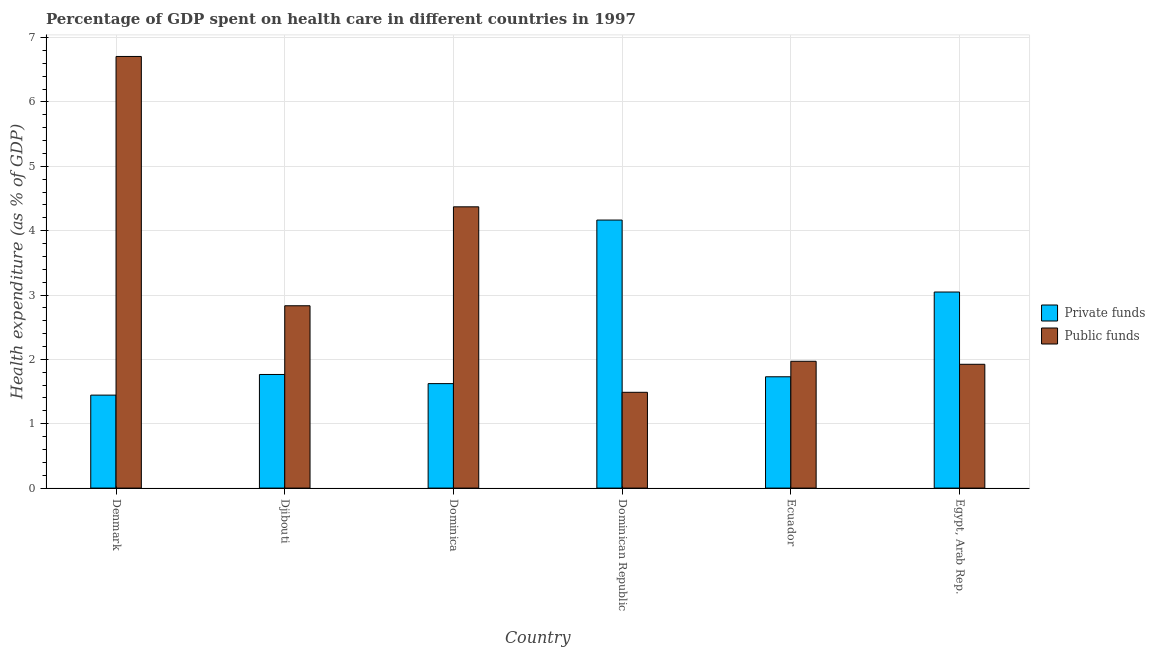How many different coloured bars are there?
Offer a terse response. 2. How many groups of bars are there?
Ensure brevity in your answer.  6. Are the number of bars per tick equal to the number of legend labels?
Your answer should be compact. Yes. Are the number of bars on each tick of the X-axis equal?
Give a very brief answer. Yes. How many bars are there on the 2nd tick from the left?
Keep it short and to the point. 2. What is the label of the 4th group of bars from the left?
Keep it short and to the point. Dominican Republic. What is the amount of public funds spent in healthcare in Egypt, Arab Rep.?
Your answer should be compact. 1.92. Across all countries, what is the maximum amount of private funds spent in healthcare?
Provide a succinct answer. 4.16. Across all countries, what is the minimum amount of public funds spent in healthcare?
Provide a succinct answer. 1.49. In which country was the amount of public funds spent in healthcare minimum?
Provide a short and direct response. Dominican Republic. What is the total amount of public funds spent in healthcare in the graph?
Make the answer very short. 19.29. What is the difference between the amount of public funds spent in healthcare in Ecuador and that in Egypt, Arab Rep.?
Offer a terse response. 0.05. What is the difference between the amount of private funds spent in healthcare in Denmark and the amount of public funds spent in healthcare in Dominica?
Offer a very short reply. -2.93. What is the average amount of public funds spent in healthcare per country?
Your answer should be compact. 3.22. What is the difference between the amount of private funds spent in healthcare and amount of public funds spent in healthcare in Egypt, Arab Rep.?
Provide a succinct answer. 1.12. In how many countries, is the amount of public funds spent in healthcare greater than 5 %?
Offer a terse response. 1. What is the ratio of the amount of private funds spent in healthcare in Denmark to that in Ecuador?
Give a very brief answer. 0.84. What is the difference between the highest and the second highest amount of public funds spent in healthcare?
Keep it short and to the point. 2.34. What is the difference between the highest and the lowest amount of public funds spent in healthcare?
Provide a short and direct response. 5.22. In how many countries, is the amount of private funds spent in healthcare greater than the average amount of private funds spent in healthcare taken over all countries?
Your answer should be compact. 2. What does the 2nd bar from the left in Denmark represents?
Keep it short and to the point. Public funds. What does the 1st bar from the right in Djibouti represents?
Make the answer very short. Public funds. How many bars are there?
Your answer should be very brief. 12. Are all the bars in the graph horizontal?
Offer a very short reply. No. How many countries are there in the graph?
Offer a very short reply. 6. What is the difference between two consecutive major ticks on the Y-axis?
Offer a terse response. 1. Does the graph contain any zero values?
Your answer should be compact. No. Where does the legend appear in the graph?
Give a very brief answer. Center right. How many legend labels are there?
Make the answer very short. 2. How are the legend labels stacked?
Ensure brevity in your answer.  Vertical. What is the title of the graph?
Give a very brief answer. Percentage of GDP spent on health care in different countries in 1997. What is the label or title of the Y-axis?
Give a very brief answer. Health expenditure (as % of GDP). What is the Health expenditure (as % of GDP) of Private funds in Denmark?
Offer a very short reply. 1.44. What is the Health expenditure (as % of GDP) in Public funds in Denmark?
Your answer should be very brief. 6.71. What is the Health expenditure (as % of GDP) in Private funds in Djibouti?
Your answer should be compact. 1.77. What is the Health expenditure (as % of GDP) of Public funds in Djibouti?
Make the answer very short. 2.83. What is the Health expenditure (as % of GDP) in Private funds in Dominica?
Provide a succinct answer. 1.62. What is the Health expenditure (as % of GDP) of Public funds in Dominica?
Your response must be concise. 4.37. What is the Health expenditure (as % of GDP) in Private funds in Dominican Republic?
Provide a short and direct response. 4.16. What is the Health expenditure (as % of GDP) in Public funds in Dominican Republic?
Provide a succinct answer. 1.49. What is the Health expenditure (as % of GDP) of Private funds in Ecuador?
Offer a terse response. 1.73. What is the Health expenditure (as % of GDP) of Public funds in Ecuador?
Provide a short and direct response. 1.97. What is the Health expenditure (as % of GDP) in Private funds in Egypt, Arab Rep.?
Provide a succinct answer. 3.05. What is the Health expenditure (as % of GDP) of Public funds in Egypt, Arab Rep.?
Provide a short and direct response. 1.92. Across all countries, what is the maximum Health expenditure (as % of GDP) of Private funds?
Provide a succinct answer. 4.16. Across all countries, what is the maximum Health expenditure (as % of GDP) of Public funds?
Offer a terse response. 6.71. Across all countries, what is the minimum Health expenditure (as % of GDP) of Private funds?
Offer a terse response. 1.44. Across all countries, what is the minimum Health expenditure (as % of GDP) in Public funds?
Make the answer very short. 1.49. What is the total Health expenditure (as % of GDP) in Private funds in the graph?
Keep it short and to the point. 13.77. What is the total Health expenditure (as % of GDP) of Public funds in the graph?
Your answer should be very brief. 19.29. What is the difference between the Health expenditure (as % of GDP) of Private funds in Denmark and that in Djibouti?
Your answer should be compact. -0.32. What is the difference between the Health expenditure (as % of GDP) in Public funds in Denmark and that in Djibouti?
Offer a very short reply. 3.87. What is the difference between the Health expenditure (as % of GDP) of Private funds in Denmark and that in Dominica?
Offer a terse response. -0.18. What is the difference between the Health expenditure (as % of GDP) of Public funds in Denmark and that in Dominica?
Provide a short and direct response. 2.34. What is the difference between the Health expenditure (as % of GDP) of Private funds in Denmark and that in Dominican Republic?
Offer a terse response. -2.72. What is the difference between the Health expenditure (as % of GDP) of Public funds in Denmark and that in Dominican Republic?
Give a very brief answer. 5.22. What is the difference between the Health expenditure (as % of GDP) of Private funds in Denmark and that in Ecuador?
Offer a terse response. -0.28. What is the difference between the Health expenditure (as % of GDP) of Public funds in Denmark and that in Ecuador?
Offer a very short reply. 4.74. What is the difference between the Health expenditure (as % of GDP) of Private funds in Denmark and that in Egypt, Arab Rep.?
Your answer should be compact. -1.6. What is the difference between the Health expenditure (as % of GDP) of Public funds in Denmark and that in Egypt, Arab Rep.?
Offer a terse response. 4.78. What is the difference between the Health expenditure (as % of GDP) of Private funds in Djibouti and that in Dominica?
Provide a succinct answer. 0.14. What is the difference between the Health expenditure (as % of GDP) in Public funds in Djibouti and that in Dominica?
Keep it short and to the point. -1.54. What is the difference between the Health expenditure (as % of GDP) of Private funds in Djibouti and that in Dominican Republic?
Your response must be concise. -2.4. What is the difference between the Health expenditure (as % of GDP) of Public funds in Djibouti and that in Dominican Republic?
Make the answer very short. 1.34. What is the difference between the Health expenditure (as % of GDP) in Private funds in Djibouti and that in Ecuador?
Your response must be concise. 0.04. What is the difference between the Health expenditure (as % of GDP) in Public funds in Djibouti and that in Ecuador?
Make the answer very short. 0.86. What is the difference between the Health expenditure (as % of GDP) of Private funds in Djibouti and that in Egypt, Arab Rep.?
Provide a succinct answer. -1.28. What is the difference between the Health expenditure (as % of GDP) of Public funds in Djibouti and that in Egypt, Arab Rep.?
Provide a short and direct response. 0.91. What is the difference between the Health expenditure (as % of GDP) in Private funds in Dominica and that in Dominican Republic?
Offer a terse response. -2.54. What is the difference between the Health expenditure (as % of GDP) in Public funds in Dominica and that in Dominican Republic?
Make the answer very short. 2.88. What is the difference between the Health expenditure (as % of GDP) in Private funds in Dominica and that in Ecuador?
Provide a short and direct response. -0.11. What is the difference between the Health expenditure (as % of GDP) in Public funds in Dominica and that in Ecuador?
Provide a succinct answer. 2.4. What is the difference between the Health expenditure (as % of GDP) of Private funds in Dominica and that in Egypt, Arab Rep.?
Make the answer very short. -1.42. What is the difference between the Health expenditure (as % of GDP) of Public funds in Dominica and that in Egypt, Arab Rep.?
Offer a very short reply. 2.45. What is the difference between the Health expenditure (as % of GDP) in Private funds in Dominican Republic and that in Ecuador?
Your response must be concise. 2.43. What is the difference between the Health expenditure (as % of GDP) of Public funds in Dominican Republic and that in Ecuador?
Offer a very short reply. -0.48. What is the difference between the Health expenditure (as % of GDP) of Private funds in Dominican Republic and that in Egypt, Arab Rep.?
Make the answer very short. 1.12. What is the difference between the Health expenditure (as % of GDP) in Public funds in Dominican Republic and that in Egypt, Arab Rep.?
Ensure brevity in your answer.  -0.44. What is the difference between the Health expenditure (as % of GDP) of Private funds in Ecuador and that in Egypt, Arab Rep.?
Offer a terse response. -1.32. What is the difference between the Health expenditure (as % of GDP) in Public funds in Ecuador and that in Egypt, Arab Rep.?
Your answer should be very brief. 0.05. What is the difference between the Health expenditure (as % of GDP) in Private funds in Denmark and the Health expenditure (as % of GDP) in Public funds in Djibouti?
Your answer should be compact. -1.39. What is the difference between the Health expenditure (as % of GDP) in Private funds in Denmark and the Health expenditure (as % of GDP) in Public funds in Dominica?
Your response must be concise. -2.93. What is the difference between the Health expenditure (as % of GDP) of Private funds in Denmark and the Health expenditure (as % of GDP) of Public funds in Dominican Republic?
Your answer should be very brief. -0.04. What is the difference between the Health expenditure (as % of GDP) of Private funds in Denmark and the Health expenditure (as % of GDP) of Public funds in Ecuador?
Your response must be concise. -0.53. What is the difference between the Health expenditure (as % of GDP) of Private funds in Denmark and the Health expenditure (as % of GDP) of Public funds in Egypt, Arab Rep.?
Give a very brief answer. -0.48. What is the difference between the Health expenditure (as % of GDP) of Private funds in Djibouti and the Health expenditure (as % of GDP) of Public funds in Dominica?
Give a very brief answer. -2.6. What is the difference between the Health expenditure (as % of GDP) in Private funds in Djibouti and the Health expenditure (as % of GDP) in Public funds in Dominican Republic?
Provide a succinct answer. 0.28. What is the difference between the Health expenditure (as % of GDP) in Private funds in Djibouti and the Health expenditure (as % of GDP) in Public funds in Ecuador?
Provide a succinct answer. -0.21. What is the difference between the Health expenditure (as % of GDP) of Private funds in Djibouti and the Health expenditure (as % of GDP) of Public funds in Egypt, Arab Rep.?
Provide a short and direct response. -0.16. What is the difference between the Health expenditure (as % of GDP) of Private funds in Dominica and the Health expenditure (as % of GDP) of Public funds in Dominican Republic?
Give a very brief answer. 0.14. What is the difference between the Health expenditure (as % of GDP) of Private funds in Dominica and the Health expenditure (as % of GDP) of Public funds in Ecuador?
Your answer should be compact. -0.35. What is the difference between the Health expenditure (as % of GDP) in Private funds in Dominica and the Health expenditure (as % of GDP) in Public funds in Egypt, Arab Rep.?
Keep it short and to the point. -0.3. What is the difference between the Health expenditure (as % of GDP) of Private funds in Dominican Republic and the Health expenditure (as % of GDP) of Public funds in Ecuador?
Offer a terse response. 2.19. What is the difference between the Health expenditure (as % of GDP) in Private funds in Dominican Republic and the Health expenditure (as % of GDP) in Public funds in Egypt, Arab Rep.?
Your answer should be very brief. 2.24. What is the difference between the Health expenditure (as % of GDP) of Private funds in Ecuador and the Health expenditure (as % of GDP) of Public funds in Egypt, Arab Rep.?
Your answer should be very brief. -0.19. What is the average Health expenditure (as % of GDP) in Private funds per country?
Offer a very short reply. 2.3. What is the average Health expenditure (as % of GDP) of Public funds per country?
Your answer should be very brief. 3.22. What is the difference between the Health expenditure (as % of GDP) of Private funds and Health expenditure (as % of GDP) of Public funds in Denmark?
Keep it short and to the point. -5.26. What is the difference between the Health expenditure (as % of GDP) of Private funds and Health expenditure (as % of GDP) of Public funds in Djibouti?
Make the answer very short. -1.07. What is the difference between the Health expenditure (as % of GDP) of Private funds and Health expenditure (as % of GDP) of Public funds in Dominica?
Your answer should be compact. -2.75. What is the difference between the Health expenditure (as % of GDP) in Private funds and Health expenditure (as % of GDP) in Public funds in Dominican Republic?
Keep it short and to the point. 2.68. What is the difference between the Health expenditure (as % of GDP) of Private funds and Health expenditure (as % of GDP) of Public funds in Ecuador?
Your answer should be compact. -0.24. What is the difference between the Health expenditure (as % of GDP) in Private funds and Health expenditure (as % of GDP) in Public funds in Egypt, Arab Rep.?
Offer a terse response. 1.12. What is the ratio of the Health expenditure (as % of GDP) in Private funds in Denmark to that in Djibouti?
Provide a short and direct response. 0.82. What is the ratio of the Health expenditure (as % of GDP) in Public funds in Denmark to that in Djibouti?
Your answer should be very brief. 2.37. What is the ratio of the Health expenditure (as % of GDP) of Private funds in Denmark to that in Dominica?
Your answer should be very brief. 0.89. What is the ratio of the Health expenditure (as % of GDP) of Public funds in Denmark to that in Dominica?
Provide a short and direct response. 1.53. What is the ratio of the Health expenditure (as % of GDP) in Private funds in Denmark to that in Dominican Republic?
Make the answer very short. 0.35. What is the ratio of the Health expenditure (as % of GDP) of Public funds in Denmark to that in Dominican Republic?
Ensure brevity in your answer.  4.51. What is the ratio of the Health expenditure (as % of GDP) of Private funds in Denmark to that in Ecuador?
Make the answer very short. 0.84. What is the ratio of the Health expenditure (as % of GDP) of Public funds in Denmark to that in Ecuador?
Your answer should be compact. 3.4. What is the ratio of the Health expenditure (as % of GDP) in Private funds in Denmark to that in Egypt, Arab Rep.?
Your response must be concise. 0.47. What is the ratio of the Health expenditure (as % of GDP) in Public funds in Denmark to that in Egypt, Arab Rep.?
Give a very brief answer. 3.49. What is the ratio of the Health expenditure (as % of GDP) in Private funds in Djibouti to that in Dominica?
Your answer should be compact. 1.09. What is the ratio of the Health expenditure (as % of GDP) of Public funds in Djibouti to that in Dominica?
Your answer should be very brief. 0.65. What is the ratio of the Health expenditure (as % of GDP) of Private funds in Djibouti to that in Dominican Republic?
Offer a very short reply. 0.42. What is the ratio of the Health expenditure (as % of GDP) of Public funds in Djibouti to that in Dominican Republic?
Offer a terse response. 1.9. What is the ratio of the Health expenditure (as % of GDP) in Private funds in Djibouti to that in Ecuador?
Ensure brevity in your answer.  1.02. What is the ratio of the Health expenditure (as % of GDP) of Public funds in Djibouti to that in Ecuador?
Make the answer very short. 1.44. What is the ratio of the Health expenditure (as % of GDP) of Private funds in Djibouti to that in Egypt, Arab Rep.?
Offer a terse response. 0.58. What is the ratio of the Health expenditure (as % of GDP) in Public funds in Djibouti to that in Egypt, Arab Rep.?
Give a very brief answer. 1.47. What is the ratio of the Health expenditure (as % of GDP) of Private funds in Dominica to that in Dominican Republic?
Keep it short and to the point. 0.39. What is the ratio of the Health expenditure (as % of GDP) in Public funds in Dominica to that in Dominican Republic?
Make the answer very short. 2.94. What is the ratio of the Health expenditure (as % of GDP) in Private funds in Dominica to that in Ecuador?
Ensure brevity in your answer.  0.94. What is the ratio of the Health expenditure (as % of GDP) of Public funds in Dominica to that in Ecuador?
Ensure brevity in your answer.  2.22. What is the ratio of the Health expenditure (as % of GDP) in Private funds in Dominica to that in Egypt, Arab Rep.?
Your response must be concise. 0.53. What is the ratio of the Health expenditure (as % of GDP) in Public funds in Dominica to that in Egypt, Arab Rep.?
Your answer should be compact. 2.27. What is the ratio of the Health expenditure (as % of GDP) of Private funds in Dominican Republic to that in Ecuador?
Your response must be concise. 2.41. What is the ratio of the Health expenditure (as % of GDP) in Public funds in Dominican Republic to that in Ecuador?
Ensure brevity in your answer.  0.76. What is the ratio of the Health expenditure (as % of GDP) of Private funds in Dominican Republic to that in Egypt, Arab Rep.?
Offer a terse response. 1.37. What is the ratio of the Health expenditure (as % of GDP) of Public funds in Dominican Republic to that in Egypt, Arab Rep.?
Provide a succinct answer. 0.77. What is the ratio of the Health expenditure (as % of GDP) in Private funds in Ecuador to that in Egypt, Arab Rep.?
Offer a terse response. 0.57. What is the ratio of the Health expenditure (as % of GDP) of Public funds in Ecuador to that in Egypt, Arab Rep.?
Make the answer very short. 1.02. What is the difference between the highest and the second highest Health expenditure (as % of GDP) of Private funds?
Provide a succinct answer. 1.12. What is the difference between the highest and the second highest Health expenditure (as % of GDP) of Public funds?
Your answer should be very brief. 2.34. What is the difference between the highest and the lowest Health expenditure (as % of GDP) of Private funds?
Provide a short and direct response. 2.72. What is the difference between the highest and the lowest Health expenditure (as % of GDP) of Public funds?
Offer a very short reply. 5.22. 